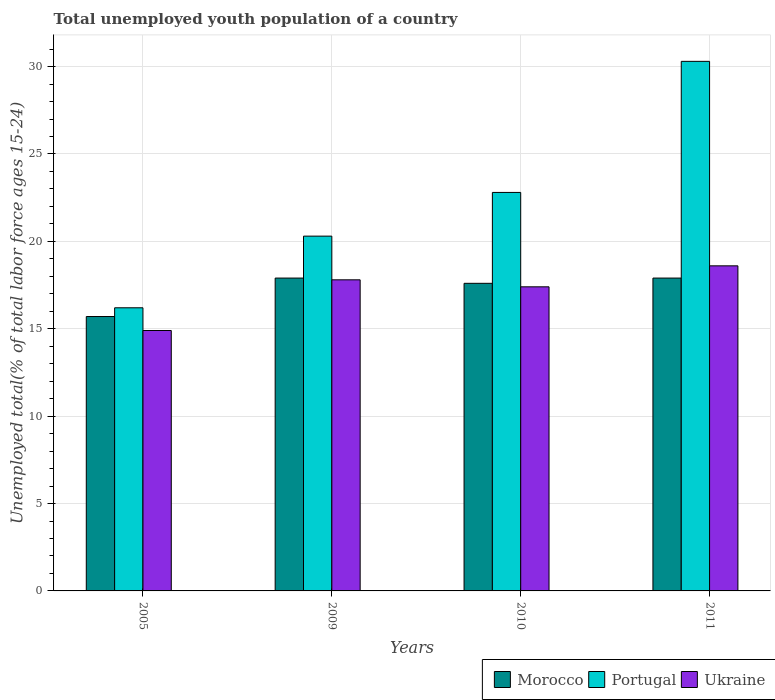How many different coloured bars are there?
Ensure brevity in your answer.  3. How many groups of bars are there?
Give a very brief answer. 4. Are the number of bars per tick equal to the number of legend labels?
Your response must be concise. Yes. What is the percentage of total unemployed youth population of a country in Ukraine in 2009?
Keep it short and to the point. 17.8. Across all years, what is the maximum percentage of total unemployed youth population of a country in Portugal?
Provide a short and direct response. 30.3. Across all years, what is the minimum percentage of total unemployed youth population of a country in Ukraine?
Provide a succinct answer. 14.9. What is the total percentage of total unemployed youth population of a country in Morocco in the graph?
Provide a short and direct response. 69.1. What is the difference between the percentage of total unemployed youth population of a country in Ukraine in 2009 and that in 2010?
Your response must be concise. 0.4. What is the difference between the percentage of total unemployed youth population of a country in Portugal in 2011 and the percentage of total unemployed youth population of a country in Ukraine in 2010?
Provide a short and direct response. 12.9. What is the average percentage of total unemployed youth population of a country in Morocco per year?
Your answer should be compact. 17.27. In the year 2011, what is the difference between the percentage of total unemployed youth population of a country in Portugal and percentage of total unemployed youth population of a country in Morocco?
Provide a short and direct response. 12.4. In how many years, is the percentage of total unemployed youth population of a country in Portugal greater than 1 %?
Provide a short and direct response. 4. What is the ratio of the percentage of total unemployed youth population of a country in Ukraine in 2010 to that in 2011?
Make the answer very short. 0.94. Is the percentage of total unemployed youth population of a country in Ukraine in 2010 less than that in 2011?
Your answer should be very brief. Yes. Is the difference between the percentage of total unemployed youth population of a country in Portugal in 2005 and 2009 greater than the difference between the percentage of total unemployed youth population of a country in Morocco in 2005 and 2009?
Provide a short and direct response. No. What is the difference between the highest and the lowest percentage of total unemployed youth population of a country in Ukraine?
Ensure brevity in your answer.  3.7. Is the sum of the percentage of total unemployed youth population of a country in Portugal in 2009 and 2011 greater than the maximum percentage of total unemployed youth population of a country in Morocco across all years?
Provide a short and direct response. Yes. What does the 2nd bar from the left in 2011 represents?
Your response must be concise. Portugal. What does the 3rd bar from the right in 2011 represents?
Your answer should be compact. Morocco. What is the difference between two consecutive major ticks on the Y-axis?
Give a very brief answer. 5. Are the values on the major ticks of Y-axis written in scientific E-notation?
Ensure brevity in your answer.  No. How many legend labels are there?
Your answer should be very brief. 3. What is the title of the graph?
Keep it short and to the point. Total unemployed youth population of a country. Does "Mauritius" appear as one of the legend labels in the graph?
Keep it short and to the point. No. What is the label or title of the X-axis?
Provide a short and direct response. Years. What is the label or title of the Y-axis?
Give a very brief answer. Unemployed total(% of total labor force ages 15-24). What is the Unemployed total(% of total labor force ages 15-24) in Morocco in 2005?
Offer a terse response. 15.7. What is the Unemployed total(% of total labor force ages 15-24) in Portugal in 2005?
Your answer should be very brief. 16.2. What is the Unemployed total(% of total labor force ages 15-24) in Ukraine in 2005?
Ensure brevity in your answer.  14.9. What is the Unemployed total(% of total labor force ages 15-24) of Morocco in 2009?
Make the answer very short. 17.9. What is the Unemployed total(% of total labor force ages 15-24) of Portugal in 2009?
Offer a terse response. 20.3. What is the Unemployed total(% of total labor force ages 15-24) in Ukraine in 2009?
Provide a short and direct response. 17.8. What is the Unemployed total(% of total labor force ages 15-24) of Morocco in 2010?
Your answer should be compact. 17.6. What is the Unemployed total(% of total labor force ages 15-24) of Portugal in 2010?
Keep it short and to the point. 22.8. What is the Unemployed total(% of total labor force ages 15-24) of Ukraine in 2010?
Keep it short and to the point. 17.4. What is the Unemployed total(% of total labor force ages 15-24) in Morocco in 2011?
Give a very brief answer. 17.9. What is the Unemployed total(% of total labor force ages 15-24) of Portugal in 2011?
Give a very brief answer. 30.3. What is the Unemployed total(% of total labor force ages 15-24) in Ukraine in 2011?
Give a very brief answer. 18.6. Across all years, what is the maximum Unemployed total(% of total labor force ages 15-24) of Morocco?
Make the answer very short. 17.9. Across all years, what is the maximum Unemployed total(% of total labor force ages 15-24) of Portugal?
Make the answer very short. 30.3. Across all years, what is the maximum Unemployed total(% of total labor force ages 15-24) in Ukraine?
Offer a very short reply. 18.6. Across all years, what is the minimum Unemployed total(% of total labor force ages 15-24) in Morocco?
Ensure brevity in your answer.  15.7. Across all years, what is the minimum Unemployed total(% of total labor force ages 15-24) of Portugal?
Your response must be concise. 16.2. Across all years, what is the minimum Unemployed total(% of total labor force ages 15-24) of Ukraine?
Offer a very short reply. 14.9. What is the total Unemployed total(% of total labor force ages 15-24) in Morocco in the graph?
Provide a short and direct response. 69.1. What is the total Unemployed total(% of total labor force ages 15-24) of Portugal in the graph?
Your answer should be compact. 89.6. What is the total Unemployed total(% of total labor force ages 15-24) in Ukraine in the graph?
Keep it short and to the point. 68.7. What is the difference between the Unemployed total(% of total labor force ages 15-24) of Portugal in 2005 and that in 2009?
Provide a succinct answer. -4.1. What is the difference between the Unemployed total(% of total labor force ages 15-24) in Ukraine in 2005 and that in 2009?
Your response must be concise. -2.9. What is the difference between the Unemployed total(% of total labor force ages 15-24) in Morocco in 2005 and that in 2010?
Provide a short and direct response. -1.9. What is the difference between the Unemployed total(% of total labor force ages 15-24) of Morocco in 2005 and that in 2011?
Make the answer very short. -2.2. What is the difference between the Unemployed total(% of total labor force ages 15-24) of Portugal in 2005 and that in 2011?
Provide a succinct answer. -14.1. What is the difference between the Unemployed total(% of total labor force ages 15-24) of Morocco in 2009 and that in 2010?
Ensure brevity in your answer.  0.3. What is the difference between the Unemployed total(% of total labor force ages 15-24) in Portugal in 2009 and that in 2010?
Keep it short and to the point. -2.5. What is the difference between the Unemployed total(% of total labor force ages 15-24) in Ukraine in 2009 and that in 2010?
Your answer should be very brief. 0.4. What is the difference between the Unemployed total(% of total labor force ages 15-24) of Morocco in 2009 and that in 2011?
Provide a succinct answer. 0. What is the difference between the Unemployed total(% of total labor force ages 15-24) of Portugal in 2009 and that in 2011?
Offer a terse response. -10. What is the difference between the Unemployed total(% of total labor force ages 15-24) of Ukraine in 2009 and that in 2011?
Make the answer very short. -0.8. What is the difference between the Unemployed total(% of total labor force ages 15-24) of Morocco in 2010 and that in 2011?
Provide a short and direct response. -0.3. What is the difference between the Unemployed total(% of total labor force ages 15-24) of Portugal in 2010 and that in 2011?
Provide a short and direct response. -7.5. What is the difference between the Unemployed total(% of total labor force ages 15-24) of Ukraine in 2010 and that in 2011?
Your answer should be compact. -1.2. What is the difference between the Unemployed total(% of total labor force ages 15-24) in Morocco in 2005 and the Unemployed total(% of total labor force ages 15-24) in Portugal in 2009?
Offer a very short reply. -4.6. What is the difference between the Unemployed total(% of total labor force ages 15-24) of Morocco in 2005 and the Unemployed total(% of total labor force ages 15-24) of Ukraine in 2010?
Provide a succinct answer. -1.7. What is the difference between the Unemployed total(% of total labor force ages 15-24) of Morocco in 2005 and the Unemployed total(% of total labor force ages 15-24) of Portugal in 2011?
Keep it short and to the point. -14.6. What is the difference between the Unemployed total(% of total labor force ages 15-24) of Portugal in 2005 and the Unemployed total(% of total labor force ages 15-24) of Ukraine in 2011?
Provide a succinct answer. -2.4. What is the difference between the Unemployed total(% of total labor force ages 15-24) of Morocco in 2009 and the Unemployed total(% of total labor force ages 15-24) of Portugal in 2010?
Keep it short and to the point. -4.9. What is the difference between the Unemployed total(% of total labor force ages 15-24) in Morocco in 2009 and the Unemployed total(% of total labor force ages 15-24) in Ukraine in 2010?
Your response must be concise. 0.5. What is the difference between the Unemployed total(% of total labor force ages 15-24) in Portugal in 2009 and the Unemployed total(% of total labor force ages 15-24) in Ukraine in 2010?
Keep it short and to the point. 2.9. What is the difference between the Unemployed total(% of total labor force ages 15-24) in Morocco in 2009 and the Unemployed total(% of total labor force ages 15-24) in Portugal in 2011?
Give a very brief answer. -12.4. What is the difference between the Unemployed total(% of total labor force ages 15-24) in Morocco in 2009 and the Unemployed total(% of total labor force ages 15-24) in Ukraine in 2011?
Keep it short and to the point. -0.7. What is the difference between the Unemployed total(% of total labor force ages 15-24) of Morocco in 2010 and the Unemployed total(% of total labor force ages 15-24) of Ukraine in 2011?
Provide a succinct answer. -1. What is the average Unemployed total(% of total labor force ages 15-24) of Morocco per year?
Provide a short and direct response. 17.27. What is the average Unemployed total(% of total labor force ages 15-24) in Portugal per year?
Ensure brevity in your answer.  22.4. What is the average Unemployed total(% of total labor force ages 15-24) in Ukraine per year?
Offer a very short reply. 17.18. In the year 2005, what is the difference between the Unemployed total(% of total labor force ages 15-24) in Morocco and Unemployed total(% of total labor force ages 15-24) in Portugal?
Provide a succinct answer. -0.5. In the year 2005, what is the difference between the Unemployed total(% of total labor force ages 15-24) in Morocco and Unemployed total(% of total labor force ages 15-24) in Ukraine?
Make the answer very short. 0.8. In the year 2010, what is the difference between the Unemployed total(% of total labor force ages 15-24) of Morocco and Unemployed total(% of total labor force ages 15-24) of Ukraine?
Your response must be concise. 0.2. What is the ratio of the Unemployed total(% of total labor force ages 15-24) of Morocco in 2005 to that in 2009?
Provide a succinct answer. 0.88. What is the ratio of the Unemployed total(% of total labor force ages 15-24) of Portugal in 2005 to that in 2009?
Ensure brevity in your answer.  0.8. What is the ratio of the Unemployed total(% of total labor force ages 15-24) in Ukraine in 2005 to that in 2009?
Your response must be concise. 0.84. What is the ratio of the Unemployed total(% of total labor force ages 15-24) in Morocco in 2005 to that in 2010?
Make the answer very short. 0.89. What is the ratio of the Unemployed total(% of total labor force ages 15-24) in Portugal in 2005 to that in 2010?
Provide a succinct answer. 0.71. What is the ratio of the Unemployed total(% of total labor force ages 15-24) of Ukraine in 2005 to that in 2010?
Your answer should be compact. 0.86. What is the ratio of the Unemployed total(% of total labor force ages 15-24) in Morocco in 2005 to that in 2011?
Your answer should be compact. 0.88. What is the ratio of the Unemployed total(% of total labor force ages 15-24) of Portugal in 2005 to that in 2011?
Provide a short and direct response. 0.53. What is the ratio of the Unemployed total(% of total labor force ages 15-24) in Ukraine in 2005 to that in 2011?
Your response must be concise. 0.8. What is the ratio of the Unemployed total(% of total labor force ages 15-24) of Portugal in 2009 to that in 2010?
Provide a succinct answer. 0.89. What is the ratio of the Unemployed total(% of total labor force ages 15-24) in Portugal in 2009 to that in 2011?
Your response must be concise. 0.67. What is the ratio of the Unemployed total(% of total labor force ages 15-24) in Morocco in 2010 to that in 2011?
Your answer should be compact. 0.98. What is the ratio of the Unemployed total(% of total labor force ages 15-24) of Portugal in 2010 to that in 2011?
Give a very brief answer. 0.75. What is the ratio of the Unemployed total(% of total labor force ages 15-24) in Ukraine in 2010 to that in 2011?
Make the answer very short. 0.94. What is the difference between the highest and the second highest Unemployed total(% of total labor force ages 15-24) of Ukraine?
Your answer should be very brief. 0.8. What is the difference between the highest and the lowest Unemployed total(% of total labor force ages 15-24) of Morocco?
Ensure brevity in your answer.  2.2. What is the difference between the highest and the lowest Unemployed total(% of total labor force ages 15-24) of Portugal?
Ensure brevity in your answer.  14.1. 